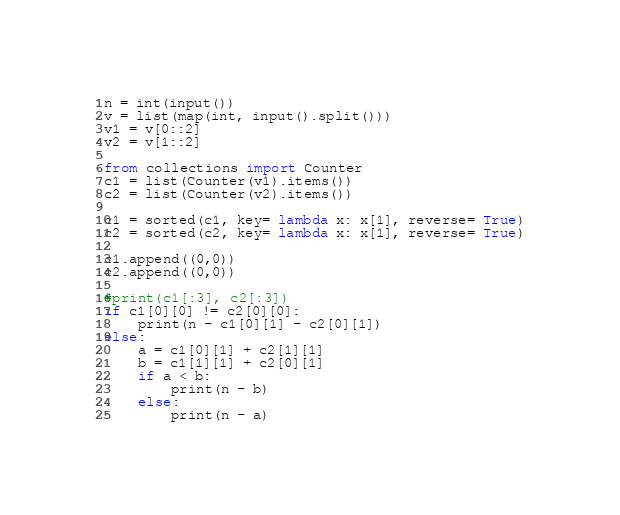<code> <loc_0><loc_0><loc_500><loc_500><_Python_>n = int(input())
v = list(map(int, input().split()))
v1 = v[0::2]
v2 = v[1::2]

from collections import Counter
c1 = list(Counter(v1).items())
c2 = list(Counter(v2).items())

c1 = sorted(c1, key= lambda x: x[1], reverse= True)
c2 = sorted(c2, key= lambda x: x[1], reverse= True)

c1.append((0,0))
c2.append((0,0))

#print(c1[:3], c2[:3])
if c1[0][0] != c2[0][0]:
    print(n - c1[0][1] - c2[0][1])
else:
    a = c1[0][1] + c2[1][1]
    b = c1[1][1] + c2[0][1]
    if a < b:
        print(n - b)
    else:
        print(n - a)</code> 